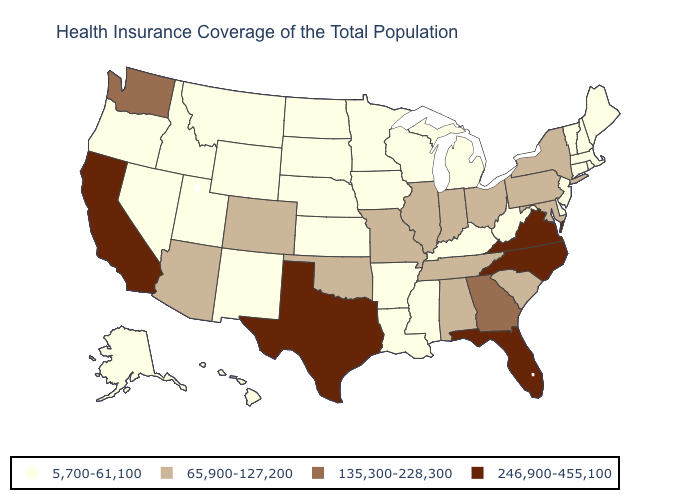What is the highest value in states that border Georgia?
Answer briefly. 246,900-455,100. What is the value of New Jersey?
Short answer required. 5,700-61,100. Does West Virginia have a lower value than Rhode Island?
Write a very short answer. No. Name the states that have a value in the range 135,300-228,300?
Give a very brief answer. Georgia, Washington. What is the value of West Virginia?
Quick response, please. 5,700-61,100. What is the lowest value in states that border Vermont?
Answer briefly. 5,700-61,100. What is the value of New Hampshire?
Short answer required. 5,700-61,100. Among the states that border Tennessee , which have the lowest value?
Keep it brief. Arkansas, Kentucky, Mississippi. Which states hav the highest value in the MidWest?
Keep it brief. Illinois, Indiana, Missouri, Ohio. Among the states that border Massachusetts , does New York have the lowest value?
Quick response, please. No. Does Colorado have a higher value than Arkansas?
Give a very brief answer. Yes. Which states have the highest value in the USA?
Answer briefly. California, Florida, North Carolina, Texas, Virginia. What is the value of North Carolina?
Be succinct. 246,900-455,100. What is the value of Kentucky?
Keep it brief. 5,700-61,100. 